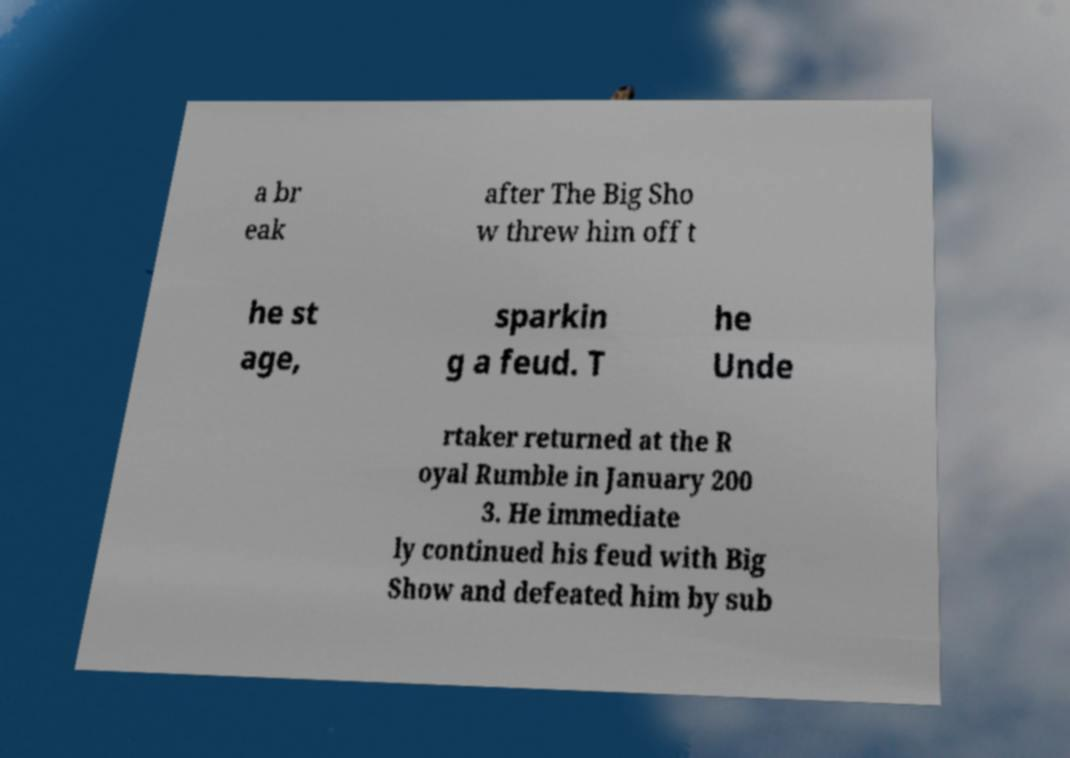Can you accurately transcribe the text from the provided image for me? a br eak after The Big Sho w threw him off t he st age, sparkin g a feud. T he Unde rtaker returned at the R oyal Rumble in January 200 3. He immediate ly continued his feud with Big Show and defeated him by sub 